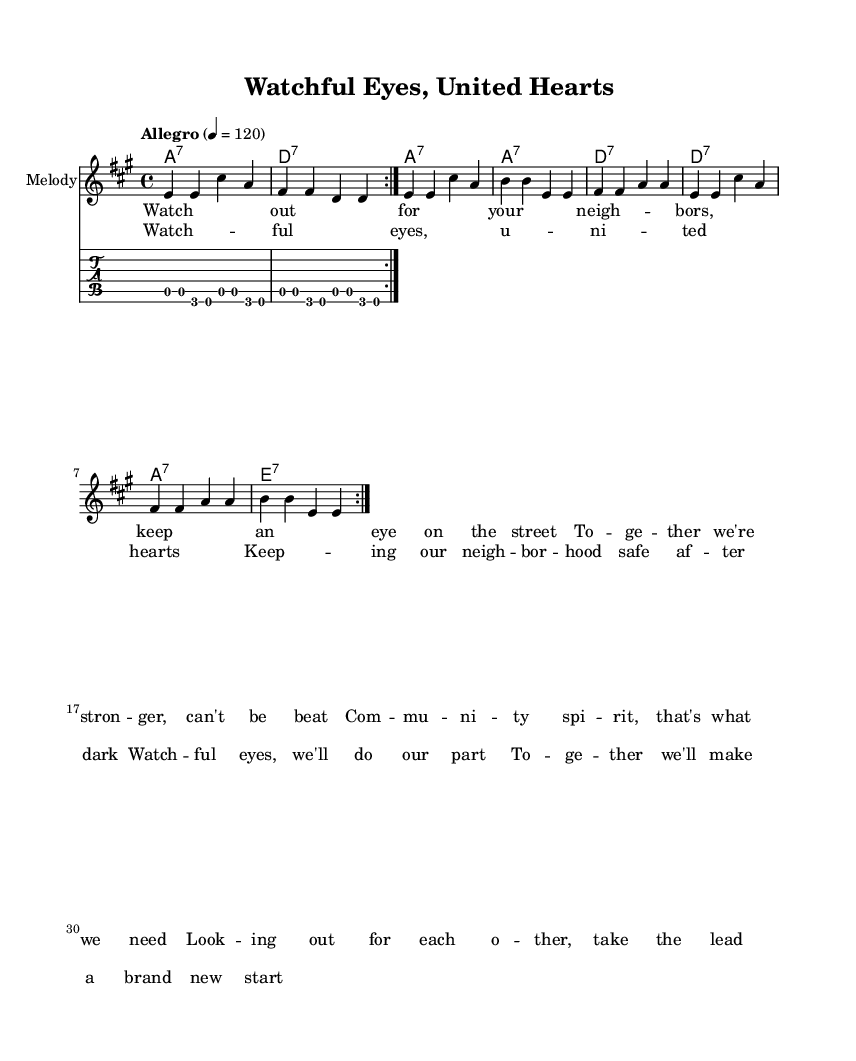What is the key signature of this music? The key signature is indicated at the beginning of the sheet music. The presence of three sharps shows that the key is A major.
Answer: A major What is the tempo marking of the piece? The tempo marking is located at the start of the score, indicating the speed at which the piece should be performed. Here, it is indicated as "Allegro" with a metronome marking of 120 beats per minute.
Answer: Allegro, 120 What is the time signature of the piece? The time signature appears near the beginning of the score. In this case, it is written as 4/4, which means there are four beats per measure, and the quarter note gets one beat.
Answer: 4/4 How many times is the melody repeated in the piece? The melody is indicated to be repeated by the "repeat volta" notation. In the score, it is specified that the melody is played twice (noted as "volta 2").
Answer: 2 What is the primary theme of the lyrics? The lyrics focus on community safety and solidarity, discussing the importance of looking out for neighbors and supporting each other, as highlighted in phrases like "Watch out for your neighbors" and "together we're stronger."
Answer: Community safety and solidarity What type of chord is used at the beginning of the harmony? The chords are displayed in a special section and the chord indicated at the beginning of the first measure is labeled as "A7," which indicates an A dominant seventh chord, characteristic of the blues genre.
Answer: A7 How is the guitar part structured? The guitar part is laid out in tab format, allowing players to see finger placements. Analyzing the tab reveals that it consists of repeated sequences played in eighth notes outlining the A, G, and E notes, common in electric blues expression.
Answer: Repeated sequences (A, G, E) 